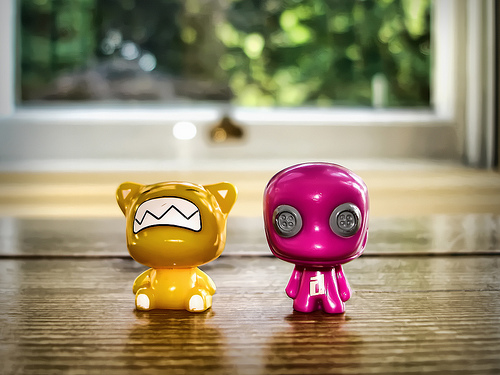<image>
Is the figurine in front of the window? Yes. The figurine is positioned in front of the window, appearing closer to the camera viewpoint. 